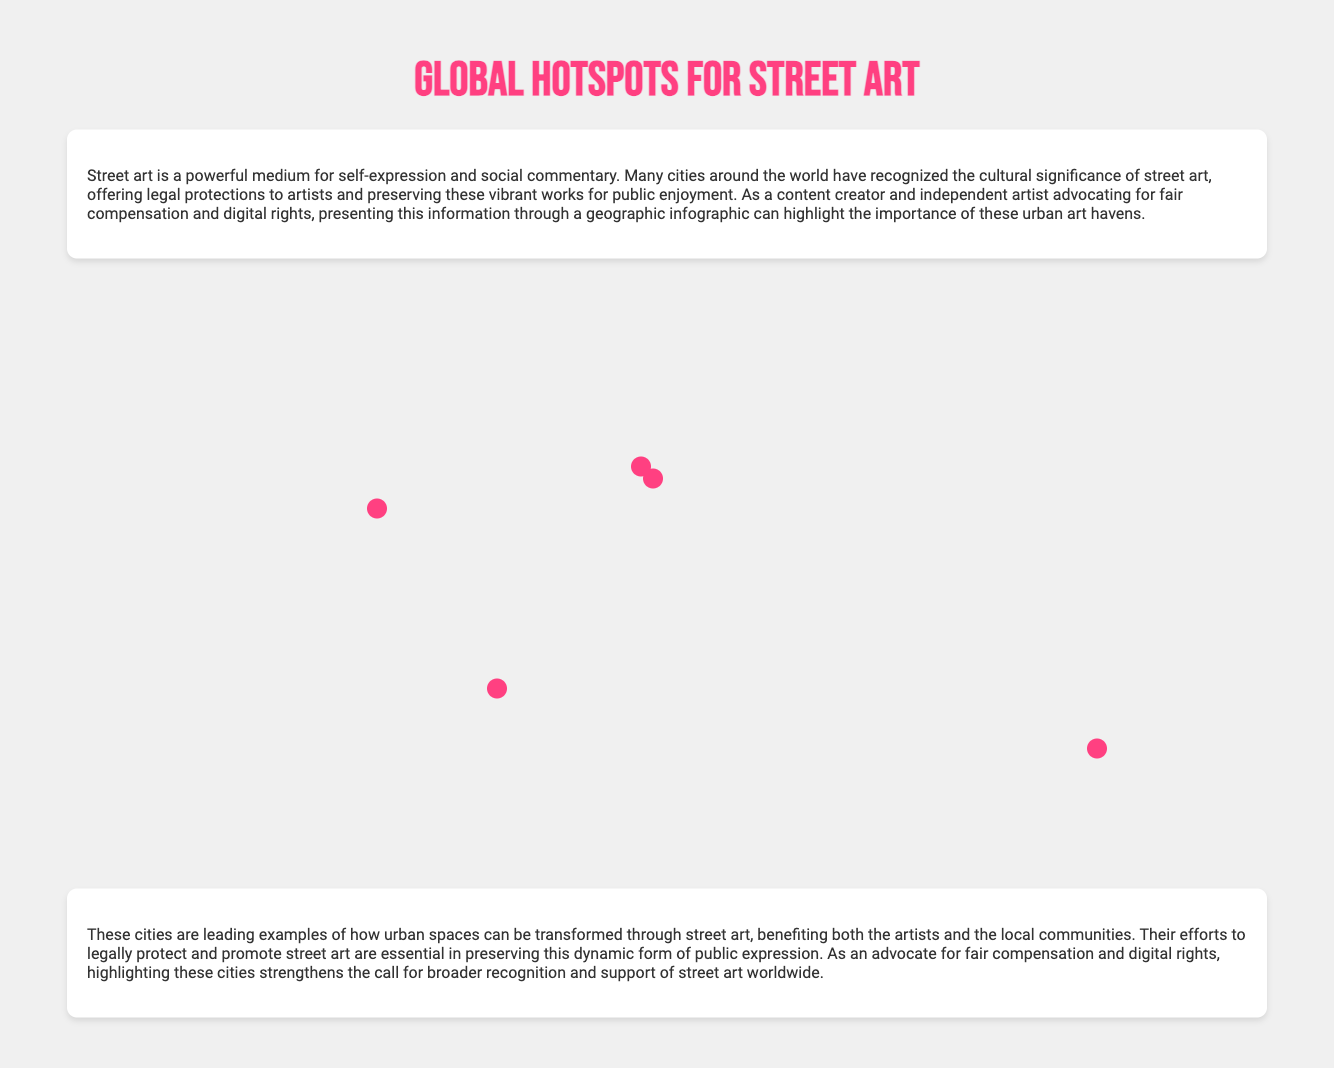What city is known for the East Side Gallery? The East Side Gallery is a famous street art location that features a long section of the Berlin Wall covered in murals, indicating that Berlin is the city known for it.
Answer: Berlin, Germany Which city features the Bushwick Collective? The Bushwick Collective is a well-known area for street art in Brooklyn, identifying New York City as the city featuring it.
Answer: New York City, USA What is the primary art district in São Paulo? The district of Vila Madalena, particularly Beco do Batman, is identified as a primary art district in São Paulo.
Answer: Vila Madalena How many murals are at the East Side Gallery? The document states there are more than 100 murals at the East Side Gallery, which provides a numerical aspect of the information.
Answer: More than 100 Which city has a legal graffiti program called "Adopt A Wall"? The "Adopt A Wall" program is mentioned as being part of New York City's initiatives, showing its connection to that specific location.
Answer: New York City Which local artist collectives are mentioned in Melbourne? The document explicitly mentions Melbourne Stencils and Everfresh Studio as local artist collectives involved in street art advocacy.
Answer: Melbourne Stencils and Everfresh Studio What color are the city markers on the map? The color of the city markers is specified in the style section of the code, denoting them as a specific shade of pink.
Answer: Pink What type of protection do all listed cities offer for street art? The document highlights that all mentioned cities provide legal protection for street art, indicating a commonality in their approach.
Answer: Legal Protection Which city is famous for its laneways that showcase street art? The laneways in Melbourne are identified as a famous location for street art, encapsulating an important characteristic of the city.
Answer: Melbourne, Australia 